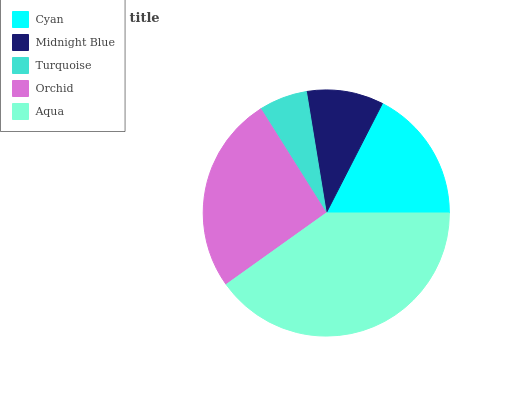Is Turquoise the minimum?
Answer yes or no. Yes. Is Aqua the maximum?
Answer yes or no. Yes. Is Midnight Blue the minimum?
Answer yes or no. No. Is Midnight Blue the maximum?
Answer yes or no. No. Is Cyan greater than Midnight Blue?
Answer yes or no. Yes. Is Midnight Blue less than Cyan?
Answer yes or no. Yes. Is Midnight Blue greater than Cyan?
Answer yes or no. No. Is Cyan less than Midnight Blue?
Answer yes or no. No. Is Cyan the high median?
Answer yes or no. Yes. Is Cyan the low median?
Answer yes or no. Yes. Is Orchid the high median?
Answer yes or no. No. Is Midnight Blue the low median?
Answer yes or no. No. 